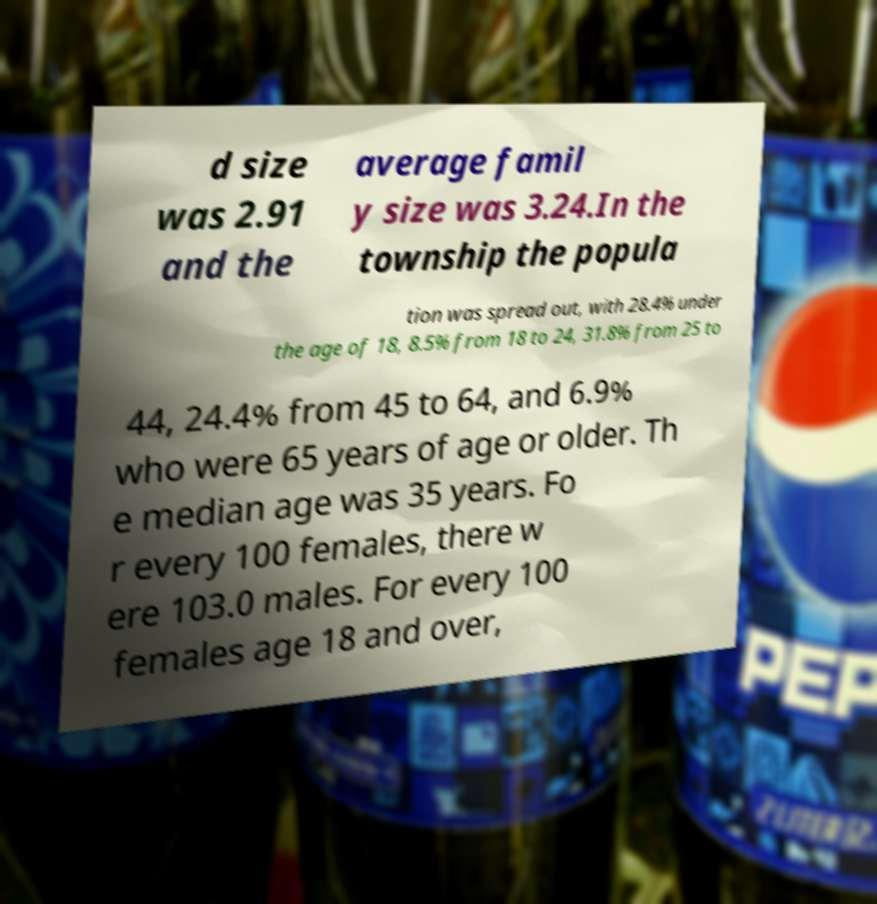I need the written content from this picture converted into text. Can you do that? d size was 2.91 and the average famil y size was 3.24.In the township the popula tion was spread out, with 28.4% under the age of 18, 8.5% from 18 to 24, 31.8% from 25 to 44, 24.4% from 45 to 64, and 6.9% who were 65 years of age or older. Th e median age was 35 years. Fo r every 100 females, there w ere 103.0 males. For every 100 females age 18 and over, 